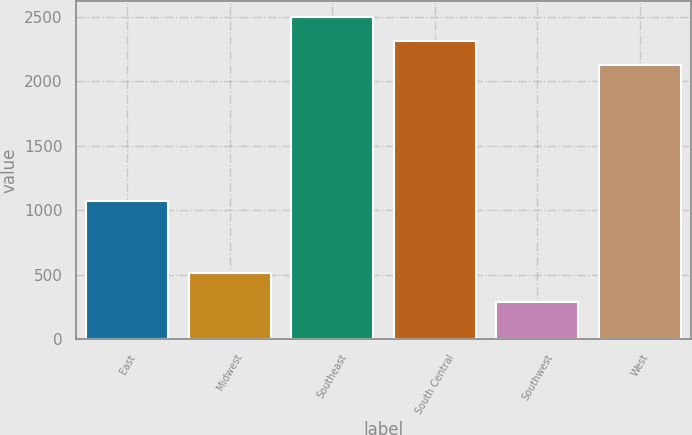<chart> <loc_0><loc_0><loc_500><loc_500><bar_chart><fcel>East<fcel>Midwest<fcel>Southeast<fcel>South Central<fcel>Southwest<fcel>West<nl><fcel>1074.2<fcel>514.9<fcel>2501.24<fcel>2313.32<fcel>285.2<fcel>2125.4<nl></chart> 